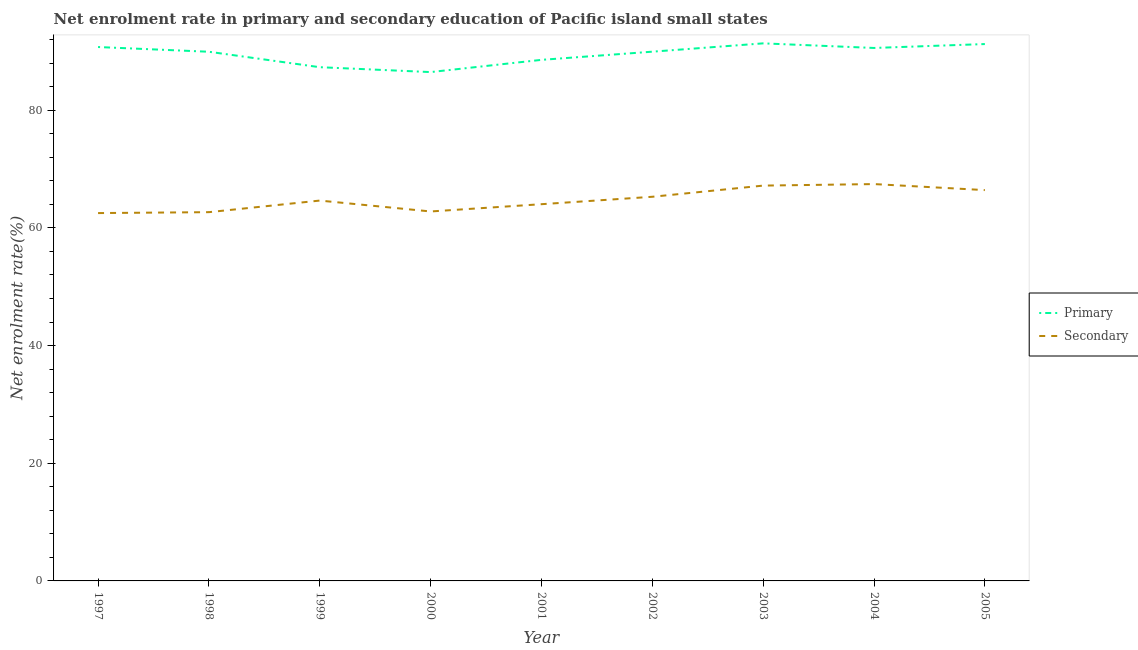Does the line corresponding to enrollment rate in primary education intersect with the line corresponding to enrollment rate in secondary education?
Offer a terse response. No. What is the enrollment rate in secondary education in 2003?
Provide a succinct answer. 67.19. Across all years, what is the maximum enrollment rate in secondary education?
Make the answer very short. 67.45. Across all years, what is the minimum enrollment rate in secondary education?
Your answer should be very brief. 62.52. In which year was the enrollment rate in secondary education maximum?
Keep it short and to the point. 2004. In which year was the enrollment rate in primary education minimum?
Provide a succinct answer. 2000. What is the total enrollment rate in secondary education in the graph?
Keep it short and to the point. 583.03. What is the difference between the enrollment rate in secondary education in 1997 and that in 1998?
Your answer should be very brief. -0.16. What is the difference between the enrollment rate in primary education in 2003 and the enrollment rate in secondary education in 1998?
Your response must be concise. 28.69. What is the average enrollment rate in primary education per year?
Provide a succinct answer. 89.58. In the year 2001, what is the difference between the enrollment rate in secondary education and enrollment rate in primary education?
Offer a terse response. -24.53. In how many years, is the enrollment rate in primary education greater than 4 %?
Your response must be concise. 9. What is the ratio of the enrollment rate in secondary education in 1999 to that in 2001?
Make the answer very short. 1.01. Is the difference between the enrollment rate in primary education in 2001 and 2003 greater than the difference between the enrollment rate in secondary education in 2001 and 2003?
Make the answer very short. Yes. What is the difference between the highest and the second highest enrollment rate in primary education?
Offer a terse response. 0.12. What is the difference between the highest and the lowest enrollment rate in primary education?
Offer a terse response. 4.88. Is the sum of the enrollment rate in primary education in 1998 and 2003 greater than the maximum enrollment rate in secondary education across all years?
Your answer should be very brief. Yes. Does the enrollment rate in secondary education monotonically increase over the years?
Provide a succinct answer. No. Is the enrollment rate in primary education strictly greater than the enrollment rate in secondary education over the years?
Your answer should be compact. Yes. How many years are there in the graph?
Your response must be concise. 9. How many legend labels are there?
Provide a short and direct response. 2. What is the title of the graph?
Your answer should be compact. Net enrolment rate in primary and secondary education of Pacific island small states. What is the label or title of the Y-axis?
Make the answer very short. Net enrolment rate(%). What is the Net enrolment rate(%) of Primary in 1997?
Your answer should be compact. 90.74. What is the Net enrolment rate(%) of Secondary in 1997?
Your answer should be compact. 62.52. What is the Net enrolment rate(%) in Primary in 1998?
Give a very brief answer. 89.94. What is the Net enrolment rate(%) in Secondary in 1998?
Make the answer very short. 62.68. What is the Net enrolment rate(%) in Primary in 1999?
Provide a succinct answer. 87.32. What is the Net enrolment rate(%) of Secondary in 1999?
Ensure brevity in your answer.  64.65. What is the Net enrolment rate(%) in Primary in 2000?
Your response must be concise. 86.49. What is the Net enrolment rate(%) of Secondary in 2000?
Offer a very short reply. 62.79. What is the Net enrolment rate(%) in Primary in 2001?
Offer a terse response. 88.56. What is the Net enrolment rate(%) of Secondary in 2001?
Offer a terse response. 64.03. What is the Net enrolment rate(%) of Primary in 2002?
Your answer should be very brief. 89.95. What is the Net enrolment rate(%) of Secondary in 2002?
Make the answer very short. 65.29. What is the Net enrolment rate(%) in Primary in 2003?
Your response must be concise. 91.37. What is the Net enrolment rate(%) in Secondary in 2003?
Your answer should be very brief. 67.19. What is the Net enrolment rate(%) of Primary in 2004?
Offer a very short reply. 90.58. What is the Net enrolment rate(%) of Secondary in 2004?
Provide a short and direct response. 67.45. What is the Net enrolment rate(%) of Primary in 2005?
Ensure brevity in your answer.  91.25. What is the Net enrolment rate(%) of Secondary in 2005?
Keep it short and to the point. 66.43. Across all years, what is the maximum Net enrolment rate(%) of Primary?
Give a very brief answer. 91.37. Across all years, what is the maximum Net enrolment rate(%) of Secondary?
Ensure brevity in your answer.  67.45. Across all years, what is the minimum Net enrolment rate(%) of Primary?
Give a very brief answer. 86.49. Across all years, what is the minimum Net enrolment rate(%) in Secondary?
Your answer should be very brief. 62.52. What is the total Net enrolment rate(%) of Primary in the graph?
Make the answer very short. 806.2. What is the total Net enrolment rate(%) in Secondary in the graph?
Give a very brief answer. 583.03. What is the difference between the Net enrolment rate(%) in Primary in 1997 and that in 1998?
Give a very brief answer. 0.8. What is the difference between the Net enrolment rate(%) in Secondary in 1997 and that in 1998?
Keep it short and to the point. -0.16. What is the difference between the Net enrolment rate(%) in Primary in 1997 and that in 1999?
Your response must be concise. 3.43. What is the difference between the Net enrolment rate(%) in Secondary in 1997 and that in 1999?
Provide a succinct answer. -2.13. What is the difference between the Net enrolment rate(%) of Primary in 1997 and that in 2000?
Keep it short and to the point. 4.26. What is the difference between the Net enrolment rate(%) of Secondary in 1997 and that in 2000?
Your response must be concise. -0.27. What is the difference between the Net enrolment rate(%) of Primary in 1997 and that in 2001?
Provide a succinct answer. 2.18. What is the difference between the Net enrolment rate(%) of Secondary in 1997 and that in 2001?
Offer a terse response. -1.51. What is the difference between the Net enrolment rate(%) in Primary in 1997 and that in 2002?
Keep it short and to the point. 0.79. What is the difference between the Net enrolment rate(%) of Secondary in 1997 and that in 2002?
Give a very brief answer. -2.77. What is the difference between the Net enrolment rate(%) in Primary in 1997 and that in 2003?
Provide a succinct answer. -0.62. What is the difference between the Net enrolment rate(%) in Secondary in 1997 and that in 2003?
Give a very brief answer. -4.67. What is the difference between the Net enrolment rate(%) in Primary in 1997 and that in 2004?
Make the answer very short. 0.16. What is the difference between the Net enrolment rate(%) in Secondary in 1997 and that in 2004?
Your answer should be very brief. -4.93. What is the difference between the Net enrolment rate(%) in Primary in 1997 and that in 2005?
Provide a succinct answer. -0.51. What is the difference between the Net enrolment rate(%) of Secondary in 1997 and that in 2005?
Provide a succinct answer. -3.9. What is the difference between the Net enrolment rate(%) in Primary in 1998 and that in 1999?
Keep it short and to the point. 2.62. What is the difference between the Net enrolment rate(%) in Secondary in 1998 and that in 1999?
Provide a short and direct response. -1.97. What is the difference between the Net enrolment rate(%) of Primary in 1998 and that in 2000?
Provide a succinct answer. 3.45. What is the difference between the Net enrolment rate(%) in Secondary in 1998 and that in 2000?
Offer a terse response. -0.12. What is the difference between the Net enrolment rate(%) of Primary in 1998 and that in 2001?
Ensure brevity in your answer.  1.38. What is the difference between the Net enrolment rate(%) in Secondary in 1998 and that in 2001?
Keep it short and to the point. -1.35. What is the difference between the Net enrolment rate(%) of Primary in 1998 and that in 2002?
Your answer should be very brief. -0.01. What is the difference between the Net enrolment rate(%) of Secondary in 1998 and that in 2002?
Keep it short and to the point. -2.62. What is the difference between the Net enrolment rate(%) of Primary in 1998 and that in 2003?
Offer a very short reply. -1.43. What is the difference between the Net enrolment rate(%) in Secondary in 1998 and that in 2003?
Give a very brief answer. -4.51. What is the difference between the Net enrolment rate(%) in Primary in 1998 and that in 2004?
Make the answer very short. -0.65. What is the difference between the Net enrolment rate(%) in Secondary in 1998 and that in 2004?
Make the answer very short. -4.77. What is the difference between the Net enrolment rate(%) of Primary in 1998 and that in 2005?
Keep it short and to the point. -1.31. What is the difference between the Net enrolment rate(%) of Secondary in 1998 and that in 2005?
Offer a terse response. -3.75. What is the difference between the Net enrolment rate(%) of Primary in 1999 and that in 2000?
Offer a very short reply. 0.83. What is the difference between the Net enrolment rate(%) in Secondary in 1999 and that in 2000?
Offer a terse response. 1.85. What is the difference between the Net enrolment rate(%) of Primary in 1999 and that in 2001?
Provide a short and direct response. -1.25. What is the difference between the Net enrolment rate(%) in Secondary in 1999 and that in 2001?
Provide a succinct answer. 0.62. What is the difference between the Net enrolment rate(%) in Primary in 1999 and that in 2002?
Provide a short and direct response. -2.64. What is the difference between the Net enrolment rate(%) of Secondary in 1999 and that in 2002?
Provide a succinct answer. -0.65. What is the difference between the Net enrolment rate(%) in Primary in 1999 and that in 2003?
Offer a very short reply. -4.05. What is the difference between the Net enrolment rate(%) of Secondary in 1999 and that in 2003?
Make the answer very short. -2.54. What is the difference between the Net enrolment rate(%) of Primary in 1999 and that in 2004?
Provide a succinct answer. -3.27. What is the difference between the Net enrolment rate(%) in Secondary in 1999 and that in 2004?
Offer a terse response. -2.8. What is the difference between the Net enrolment rate(%) of Primary in 1999 and that in 2005?
Your response must be concise. -3.93. What is the difference between the Net enrolment rate(%) in Secondary in 1999 and that in 2005?
Offer a very short reply. -1.78. What is the difference between the Net enrolment rate(%) in Primary in 2000 and that in 2001?
Your answer should be compact. -2.08. What is the difference between the Net enrolment rate(%) in Secondary in 2000 and that in 2001?
Your response must be concise. -1.24. What is the difference between the Net enrolment rate(%) of Primary in 2000 and that in 2002?
Your answer should be compact. -3.47. What is the difference between the Net enrolment rate(%) in Secondary in 2000 and that in 2002?
Offer a very short reply. -2.5. What is the difference between the Net enrolment rate(%) in Primary in 2000 and that in 2003?
Make the answer very short. -4.88. What is the difference between the Net enrolment rate(%) of Secondary in 2000 and that in 2003?
Make the answer very short. -4.4. What is the difference between the Net enrolment rate(%) in Primary in 2000 and that in 2004?
Ensure brevity in your answer.  -4.1. What is the difference between the Net enrolment rate(%) in Secondary in 2000 and that in 2004?
Give a very brief answer. -4.66. What is the difference between the Net enrolment rate(%) of Primary in 2000 and that in 2005?
Make the answer very short. -4.76. What is the difference between the Net enrolment rate(%) in Secondary in 2000 and that in 2005?
Your answer should be very brief. -3.63. What is the difference between the Net enrolment rate(%) of Primary in 2001 and that in 2002?
Offer a very short reply. -1.39. What is the difference between the Net enrolment rate(%) in Secondary in 2001 and that in 2002?
Provide a succinct answer. -1.26. What is the difference between the Net enrolment rate(%) in Primary in 2001 and that in 2003?
Ensure brevity in your answer.  -2.8. What is the difference between the Net enrolment rate(%) of Secondary in 2001 and that in 2003?
Provide a short and direct response. -3.16. What is the difference between the Net enrolment rate(%) in Primary in 2001 and that in 2004?
Make the answer very short. -2.02. What is the difference between the Net enrolment rate(%) of Secondary in 2001 and that in 2004?
Make the answer very short. -3.42. What is the difference between the Net enrolment rate(%) in Primary in 2001 and that in 2005?
Your response must be concise. -2.69. What is the difference between the Net enrolment rate(%) of Secondary in 2001 and that in 2005?
Make the answer very short. -2.39. What is the difference between the Net enrolment rate(%) in Primary in 2002 and that in 2003?
Your answer should be very brief. -1.41. What is the difference between the Net enrolment rate(%) in Secondary in 2002 and that in 2003?
Provide a short and direct response. -1.9. What is the difference between the Net enrolment rate(%) in Primary in 2002 and that in 2004?
Give a very brief answer. -0.63. What is the difference between the Net enrolment rate(%) of Secondary in 2002 and that in 2004?
Your response must be concise. -2.16. What is the difference between the Net enrolment rate(%) in Primary in 2002 and that in 2005?
Your response must be concise. -1.3. What is the difference between the Net enrolment rate(%) in Secondary in 2002 and that in 2005?
Your answer should be compact. -1.13. What is the difference between the Net enrolment rate(%) in Primary in 2003 and that in 2004?
Give a very brief answer. 0.78. What is the difference between the Net enrolment rate(%) of Secondary in 2003 and that in 2004?
Your answer should be very brief. -0.26. What is the difference between the Net enrolment rate(%) in Primary in 2003 and that in 2005?
Ensure brevity in your answer.  0.12. What is the difference between the Net enrolment rate(%) in Secondary in 2003 and that in 2005?
Your answer should be compact. 0.77. What is the difference between the Net enrolment rate(%) of Primary in 2004 and that in 2005?
Your answer should be compact. -0.67. What is the difference between the Net enrolment rate(%) in Secondary in 2004 and that in 2005?
Ensure brevity in your answer.  1.02. What is the difference between the Net enrolment rate(%) of Primary in 1997 and the Net enrolment rate(%) of Secondary in 1998?
Your answer should be very brief. 28.07. What is the difference between the Net enrolment rate(%) of Primary in 1997 and the Net enrolment rate(%) of Secondary in 1999?
Provide a short and direct response. 26.1. What is the difference between the Net enrolment rate(%) of Primary in 1997 and the Net enrolment rate(%) of Secondary in 2000?
Keep it short and to the point. 27.95. What is the difference between the Net enrolment rate(%) in Primary in 1997 and the Net enrolment rate(%) in Secondary in 2001?
Ensure brevity in your answer.  26.71. What is the difference between the Net enrolment rate(%) in Primary in 1997 and the Net enrolment rate(%) in Secondary in 2002?
Offer a terse response. 25.45. What is the difference between the Net enrolment rate(%) of Primary in 1997 and the Net enrolment rate(%) of Secondary in 2003?
Your answer should be compact. 23.55. What is the difference between the Net enrolment rate(%) in Primary in 1997 and the Net enrolment rate(%) in Secondary in 2004?
Make the answer very short. 23.29. What is the difference between the Net enrolment rate(%) of Primary in 1997 and the Net enrolment rate(%) of Secondary in 2005?
Give a very brief answer. 24.32. What is the difference between the Net enrolment rate(%) of Primary in 1998 and the Net enrolment rate(%) of Secondary in 1999?
Offer a very short reply. 25.29. What is the difference between the Net enrolment rate(%) in Primary in 1998 and the Net enrolment rate(%) in Secondary in 2000?
Give a very brief answer. 27.14. What is the difference between the Net enrolment rate(%) in Primary in 1998 and the Net enrolment rate(%) in Secondary in 2001?
Provide a succinct answer. 25.91. What is the difference between the Net enrolment rate(%) in Primary in 1998 and the Net enrolment rate(%) in Secondary in 2002?
Offer a terse response. 24.65. What is the difference between the Net enrolment rate(%) of Primary in 1998 and the Net enrolment rate(%) of Secondary in 2003?
Offer a very short reply. 22.75. What is the difference between the Net enrolment rate(%) in Primary in 1998 and the Net enrolment rate(%) in Secondary in 2004?
Offer a terse response. 22.49. What is the difference between the Net enrolment rate(%) of Primary in 1998 and the Net enrolment rate(%) of Secondary in 2005?
Your answer should be compact. 23.51. What is the difference between the Net enrolment rate(%) of Primary in 1999 and the Net enrolment rate(%) of Secondary in 2000?
Ensure brevity in your answer.  24.52. What is the difference between the Net enrolment rate(%) in Primary in 1999 and the Net enrolment rate(%) in Secondary in 2001?
Ensure brevity in your answer.  23.28. What is the difference between the Net enrolment rate(%) of Primary in 1999 and the Net enrolment rate(%) of Secondary in 2002?
Offer a very short reply. 22.02. What is the difference between the Net enrolment rate(%) of Primary in 1999 and the Net enrolment rate(%) of Secondary in 2003?
Give a very brief answer. 20.12. What is the difference between the Net enrolment rate(%) in Primary in 1999 and the Net enrolment rate(%) in Secondary in 2004?
Provide a short and direct response. 19.87. What is the difference between the Net enrolment rate(%) of Primary in 1999 and the Net enrolment rate(%) of Secondary in 2005?
Provide a succinct answer. 20.89. What is the difference between the Net enrolment rate(%) in Primary in 2000 and the Net enrolment rate(%) in Secondary in 2001?
Provide a succinct answer. 22.45. What is the difference between the Net enrolment rate(%) in Primary in 2000 and the Net enrolment rate(%) in Secondary in 2002?
Offer a very short reply. 21.19. What is the difference between the Net enrolment rate(%) in Primary in 2000 and the Net enrolment rate(%) in Secondary in 2003?
Provide a succinct answer. 19.29. What is the difference between the Net enrolment rate(%) in Primary in 2000 and the Net enrolment rate(%) in Secondary in 2004?
Ensure brevity in your answer.  19.04. What is the difference between the Net enrolment rate(%) in Primary in 2000 and the Net enrolment rate(%) in Secondary in 2005?
Your answer should be very brief. 20.06. What is the difference between the Net enrolment rate(%) of Primary in 2001 and the Net enrolment rate(%) of Secondary in 2002?
Your answer should be compact. 23.27. What is the difference between the Net enrolment rate(%) in Primary in 2001 and the Net enrolment rate(%) in Secondary in 2003?
Offer a very short reply. 21.37. What is the difference between the Net enrolment rate(%) of Primary in 2001 and the Net enrolment rate(%) of Secondary in 2004?
Offer a terse response. 21.11. What is the difference between the Net enrolment rate(%) in Primary in 2001 and the Net enrolment rate(%) in Secondary in 2005?
Your answer should be compact. 22.14. What is the difference between the Net enrolment rate(%) of Primary in 2002 and the Net enrolment rate(%) of Secondary in 2003?
Offer a very short reply. 22.76. What is the difference between the Net enrolment rate(%) in Primary in 2002 and the Net enrolment rate(%) in Secondary in 2004?
Make the answer very short. 22.5. What is the difference between the Net enrolment rate(%) in Primary in 2002 and the Net enrolment rate(%) in Secondary in 2005?
Offer a terse response. 23.53. What is the difference between the Net enrolment rate(%) in Primary in 2003 and the Net enrolment rate(%) in Secondary in 2004?
Give a very brief answer. 23.92. What is the difference between the Net enrolment rate(%) in Primary in 2003 and the Net enrolment rate(%) in Secondary in 2005?
Offer a terse response. 24.94. What is the difference between the Net enrolment rate(%) of Primary in 2004 and the Net enrolment rate(%) of Secondary in 2005?
Offer a terse response. 24.16. What is the average Net enrolment rate(%) in Primary per year?
Make the answer very short. 89.58. What is the average Net enrolment rate(%) of Secondary per year?
Your answer should be compact. 64.78. In the year 1997, what is the difference between the Net enrolment rate(%) of Primary and Net enrolment rate(%) of Secondary?
Offer a very short reply. 28.22. In the year 1998, what is the difference between the Net enrolment rate(%) of Primary and Net enrolment rate(%) of Secondary?
Your answer should be compact. 27.26. In the year 1999, what is the difference between the Net enrolment rate(%) in Primary and Net enrolment rate(%) in Secondary?
Your answer should be very brief. 22.67. In the year 2000, what is the difference between the Net enrolment rate(%) of Primary and Net enrolment rate(%) of Secondary?
Keep it short and to the point. 23.69. In the year 2001, what is the difference between the Net enrolment rate(%) of Primary and Net enrolment rate(%) of Secondary?
Ensure brevity in your answer.  24.53. In the year 2002, what is the difference between the Net enrolment rate(%) in Primary and Net enrolment rate(%) in Secondary?
Offer a very short reply. 24.66. In the year 2003, what is the difference between the Net enrolment rate(%) of Primary and Net enrolment rate(%) of Secondary?
Offer a very short reply. 24.18. In the year 2004, what is the difference between the Net enrolment rate(%) of Primary and Net enrolment rate(%) of Secondary?
Keep it short and to the point. 23.13. In the year 2005, what is the difference between the Net enrolment rate(%) in Primary and Net enrolment rate(%) in Secondary?
Your answer should be compact. 24.82. What is the ratio of the Net enrolment rate(%) in Primary in 1997 to that in 1998?
Offer a very short reply. 1.01. What is the ratio of the Net enrolment rate(%) of Primary in 1997 to that in 1999?
Your answer should be compact. 1.04. What is the ratio of the Net enrolment rate(%) in Secondary in 1997 to that in 1999?
Keep it short and to the point. 0.97. What is the ratio of the Net enrolment rate(%) of Primary in 1997 to that in 2000?
Offer a terse response. 1.05. What is the ratio of the Net enrolment rate(%) in Secondary in 1997 to that in 2000?
Keep it short and to the point. 1. What is the ratio of the Net enrolment rate(%) of Primary in 1997 to that in 2001?
Offer a terse response. 1.02. What is the ratio of the Net enrolment rate(%) in Secondary in 1997 to that in 2001?
Ensure brevity in your answer.  0.98. What is the ratio of the Net enrolment rate(%) in Primary in 1997 to that in 2002?
Your response must be concise. 1.01. What is the ratio of the Net enrolment rate(%) in Secondary in 1997 to that in 2002?
Offer a very short reply. 0.96. What is the ratio of the Net enrolment rate(%) in Secondary in 1997 to that in 2003?
Your response must be concise. 0.93. What is the ratio of the Net enrolment rate(%) of Secondary in 1997 to that in 2004?
Make the answer very short. 0.93. What is the ratio of the Net enrolment rate(%) in Secondary in 1998 to that in 1999?
Offer a very short reply. 0.97. What is the ratio of the Net enrolment rate(%) in Primary in 1998 to that in 2000?
Keep it short and to the point. 1.04. What is the ratio of the Net enrolment rate(%) of Primary in 1998 to that in 2001?
Offer a terse response. 1.02. What is the ratio of the Net enrolment rate(%) in Secondary in 1998 to that in 2001?
Provide a succinct answer. 0.98. What is the ratio of the Net enrolment rate(%) of Secondary in 1998 to that in 2002?
Your answer should be very brief. 0.96. What is the ratio of the Net enrolment rate(%) in Primary in 1998 to that in 2003?
Provide a short and direct response. 0.98. What is the ratio of the Net enrolment rate(%) of Secondary in 1998 to that in 2003?
Offer a very short reply. 0.93. What is the ratio of the Net enrolment rate(%) of Secondary in 1998 to that in 2004?
Ensure brevity in your answer.  0.93. What is the ratio of the Net enrolment rate(%) of Primary in 1998 to that in 2005?
Provide a succinct answer. 0.99. What is the ratio of the Net enrolment rate(%) in Secondary in 1998 to that in 2005?
Your response must be concise. 0.94. What is the ratio of the Net enrolment rate(%) in Primary in 1999 to that in 2000?
Give a very brief answer. 1.01. What is the ratio of the Net enrolment rate(%) of Secondary in 1999 to that in 2000?
Offer a terse response. 1.03. What is the ratio of the Net enrolment rate(%) in Primary in 1999 to that in 2001?
Your response must be concise. 0.99. What is the ratio of the Net enrolment rate(%) of Secondary in 1999 to that in 2001?
Provide a succinct answer. 1.01. What is the ratio of the Net enrolment rate(%) of Primary in 1999 to that in 2002?
Ensure brevity in your answer.  0.97. What is the ratio of the Net enrolment rate(%) of Secondary in 1999 to that in 2002?
Give a very brief answer. 0.99. What is the ratio of the Net enrolment rate(%) in Primary in 1999 to that in 2003?
Provide a succinct answer. 0.96. What is the ratio of the Net enrolment rate(%) of Secondary in 1999 to that in 2003?
Ensure brevity in your answer.  0.96. What is the ratio of the Net enrolment rate(%) in Primary in 1999 to that in 2004?
Keep it short and to the point. 0.96. What is the ratio of the Net enrolment rate(%) in Secondary in 1999 to that in 2004?
Give a very brief answer. 0.96. What is the ratio of the Net enrolment rate(%) in Primary in 1999 to that in 2005?
Your answer should be compact. 0.96. What is the ratio of the Net enrolment rate(%) in Secondary in 1999 to that in 2005?
Keep it short and to the point. 0.97. What is the ratio of the Net enrolment rate(%) of Primary in 2000 to that in 2001?
Give a very brief answer. 0.98. What is the ratio of the Net enrolment rate(%) of Secondary in 2000 to that in 2001?
Your answer should be compact. 0.98. What is the ratio of the Net enrolment rate(%) in Primary in 2000 to that in 2002?
Make the answer very short. 0.96. What is the ratio of the Net enrolment rate(%) of Secondary in 2000 to that in 2002?
Your answer should be very brief. 0.96. What is the ratio of the Net enrolment rate(%) in Primary in 2000 to that in 2003?
Give a very brief answer. 0.95. What is the ratio of the Net enrolment rate(%) in Secondary in 2000 to that in 2003?
Keep it short and to the point. 0.93. What is the ratio of the Net enrolment rate(%) in Primary in 2000 to that in 2004?
Provide a short and direct response. 0.95. What is the ratio of the Net enrolment rate(%) of Primary in 2000 to that in 2005?
Your response must be concise. 0.95. What is the ratio of the Net enrolment rate(%) of Secondary in 2000 to that in 2005?
Your answer should be compact. 0.95. What is the ratio of the Net enrolment rate(%) of Primary in 2001 to that in 2002?
Your answer should be very brief. 0.98. What is the ratio of the Net enrolment rate(%) of Secondary in 2001 to that in 2002?
Give a very brief answer. 0.98. What is the ratio of the Net enrolment rate(%) of Primary in 2001 to that in 2003?
Give a very brief answer. 0.97. What is the ratio of the Net enrolment rate(%) of Secondary in 2001 to that in 2003?
Your answer should be compact. 0.95. What is the ratio of the Net enrolment rate(%) in Primary in 2001 to that in 2004?
Provide a succinct answer. 0.98. What is the ratio of the Net enrolment rate(%) in Secondary in 2001 to that in 2004?
Make the answer very short. 0.95. What is the ratio of the Net enrolment rate(%) in Primary in 2001 to that in 2005?
Give a very brief answer. 0.97. What is the ratio of the Net enrolment rate(%) of Secondary in 2001 to that in 2005?
Ensure brevity in your answer.  0.96. What is the ratio of the Net enrolment rate(%) of Primary in 2002 to that in 2003?
Your answer should be compact. 0.98. What is the ratio of the Net enrolment rate(%) in Secondary in 2002 to that in 2003?
Ensure brevity in your answer.  0.97. What is the ratio of the Net enrolment rate(%) of Primary in 2002 to that in 2004?
Your answer should be compact. 0.99. What is the ratio of the Net enrolment rate(%) of Secondary in 2002 to that in 2004?
Provide a short and direct response. 0.97. What is the ratio of the Net enrolment rate(%) in Primary in 2002 to that in 2005?
Offer a very short reply. 0.99. What is the ratio of the Net enrolment rate(%) in Secondary in 2002 to that in 2005?
Offer a terse response. 0.98. What is the ratio of the Net enrolment rate(%) in Primary in 2003 to that in 2004?
Your answer should be compact. 1.01. What is the ratio of the Net enrolment rate(%) in Secondary in 2003 to that in 2004?
Give a very brief answer. 1. What is the ratio of the Net enrolment rate(%) of Primary in 2003 to that in 2005?
Your response must be concise. 1. What is the ratio of the Net enrolment rate(%) in Secondary in 2003 to that in 2005?
Give a very brief answer. 1.01. What is the ratio of the Net enrolment rate(%) in Secondary in 2004 to that in 2005?
Give a very brief answer. 1.02. What is the difference between the highest and the second highest Net enrolment rate(%) in Primary?
Provide a succinct answer. 0.12. What is the difference between the highest and the second highest Net enrolment rate(%) of Secondary?
Offer a very short reply. 0.26. What is the difference between the highest and the lowest Net enrolment rate(%) of Primary?
Provide a succinct answer. 4.88. What is the difference between the highest and the lowest Net enrolment rate(%) of Secondary?
Offer a very short reply. 4.93. 